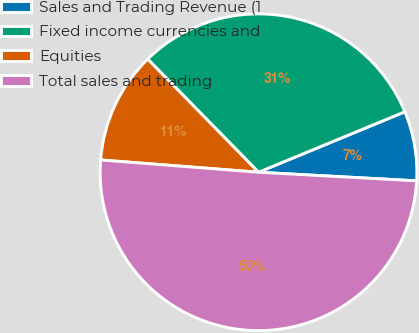Convert chart to OTSL. <chart><loc_0><loc_0><loc_500><loc_500><pie_chart><fcel>Sales and Trading Revenue (1<fcel>Fixed income currencies and<fcel>Equities<fcel>Total sales and trading<nl><fcel>7.1%<fcel>31.1%<fcel>11.43%<fcel>50.37%<nl></chart> 